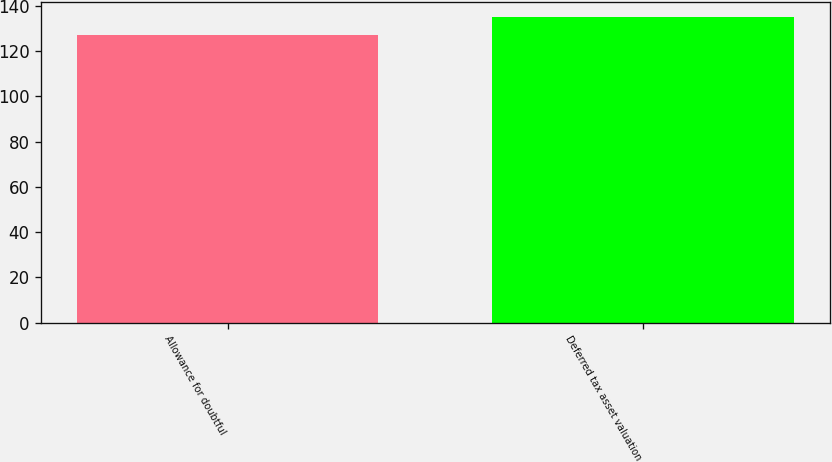Convert chart to OTSL. <chart><loc_0><loc_0><loc_500><loc_500><bar_chart><fcel>Allowance for doubtful<fcel>Deferred tax asset valuation<nl><fcel>127<fcel>135<nl></chart> 